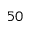Convert formula to latex. <formula><loc_0><loc_0><loc_500><loc_500>5 0</formula> 